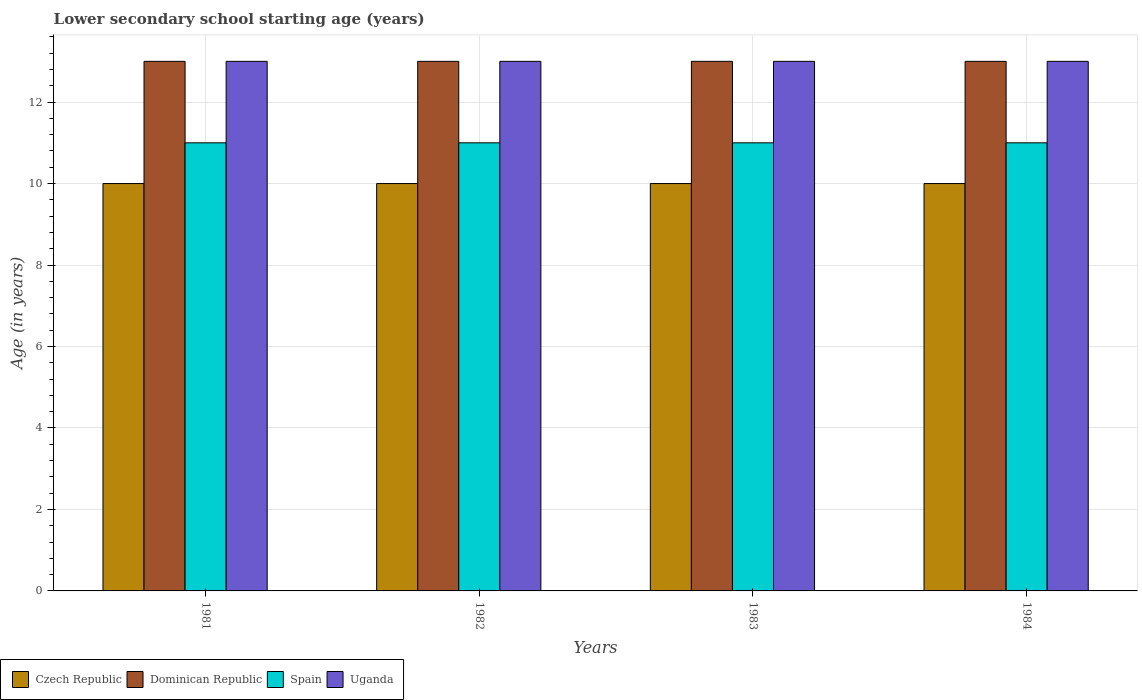How many different coloured bars are there?
Keep it short and to the point. 4. Are the number of bars per tick equal to the number of legend labels?
Give a very brief answer. Yes. In how many cases, is the number of bars for a given year not equal to the number of legend labels?
Your answer should be very brief. 0. What is the lower secondary school starting age of children in Uganda in 1984?
Provide a short and direct response. 13. Across all years, what is the maximum lower secondary school starting age of children in Spain?
Your response must be concise. 11. Across all years, what is the minimum lower secondary school starting age of children in Czech Republic?
Your answer should be very brief. 10. What is the total lower secondary school starting age of children in Czech Republic in the graph?
Offer a terse response. 40. What is the difference between the lower secondary school starting age of children in Dominican Republic in 1981 and that in 1983?
Your response must be concise. 0. What is the difference between the lower secondary school starting age of children in Czech Republic in 1982 and the lower secondary school starting age of children in Dominican Republic in 1983?
Offer a terse response. -3. In the year 1984, what is the difference between the lower secondary school starting age of children in Uganda and lower secondary school starting age of children in Czech Republic?
Ensure brevity in your answer.  3. In how many years, is the lower secondary school starting age of children in Dominican Republic greater than 8.8 years?
Provide a short and direct response. 4. What is the ratio of the lower secondary school starting age of children in Spain in 1981 to that in 1982?
Your response must be concise. 1. Is the lower secondary school starting age of children in Dominican Republic in 1981 less than that in 1984?
Your answer should be very brief. No. What is the difference between the highest and the lowest lower secondary school starting age of children in Spain?
Make the answer very short. 0. Is it the case that in every year, the sum of the lower secondary school starting age of children in Spain and lower secondary school starting age of children in Dominican Republic is greater than the sum of lower secondary school starting age of children in Uganda and lower secondary school starting age of children in Czech Republic?
Make the answer very short. Yes. What does the 2nd bar from the left in 1982 represents?
Provide a succinct answer. Dominican Republic. What does the 3rd bar from the right in 1984 represents?
Offer a terse response. Dominican Republic. How many bars are there?
Give a very brief answer. 16. Are all the bars in the graph horizontal?
Offer a terse response. No. How many years are there in the graph?
Provide a short and direct response. 4. What is the difference between two consecutive major ticks on the Y-axis?
Your answer should be very brief. 2. Are the values on the major ticks of Y-axis written in scientific E-notation?
Make the answer very short. No. Does the graph contain any zero values?
Offer a terse response. No. Does the graph contain grids?
Your answer should be very brief. Yes. Where does the legend appear in the graph?
Your answer should be compact. Bottom left. How are the legend labels stacked?
Ensure brevity in your answer.  Horizontal. What is the title of the graph?
Your response must be concise. Lower secondary school starting age (years). What is the label or title of the X-axis?
Ensure brevity in your answer.  Years. What is the label or title of the Y-axis?
Your answer should be very brief. Age (in years). What is the Age (in years) of Czech Republic in 1982?
Keep it short and to the point. 10. What is the Age (in years) in Czech Republic in 1983?
Ensure brevity in your answer.  10. What is the Age (in years) in Uganda in 1983?
Keep it short and to the point. 13. What is the Age (in years) of Czech Republic in 1984?
Provide a succinct answer. 10. What is the Age (in years) in Dominican Republic in 1984?
Offer a terse response. 13. Across all years, what is the minimum Age (in years) of Dominican Republic?
Your answer should be very brief. 13. What is the total Age (in years) of Spain in the graph?
Your response must be concise. 44. What is the difference between the Age (in years) of Dominican Republic in 1981 and that in 1982?
Provide a short and direct response. 0. What is the difference between the Age (in years) of Spain in 1981 and that in 1982?
Ensure brevity in your answer.  0. What is the difference between the Age (in years) in Uganda in 1981 and that in 1982?
Offer a very short reply. 0. What is the difference between the Age (in years) of Dominican Republic in 1981 and that in 1983?
Your response must be concise. 0. What is the difference between the Age (in years) of Spain in 1981 and that in 1983?
Your response must be concise. 0. What is the difference between the Age (in years) of Czech Republic in 1981 and that in 1984?
Make the answer very short. 0. What is the difference between the Age (in years) of Dominican Republic in 1981 and that in 1984?
Keep it short and to the point. 0. What is the difference between the Age (in years) of Spain in 1981 and that in 1984?
Your answer should be compact. 0. What is the difference between the Age (in years) of Czech Republic in 1982 and that in 1983?
Offer a very short reply. 0. What is the difference between the Age (in years) in Dominican Republic in 1982 and that in 1984?
Provide a short and direct response. 0. What is the difference between the Age (in years) in Spain in 1982 and that in 1984?
Your response must be concise. 0. What is the difference between the Age (in years) in Czech Republic in 1983 and that in 1984?
Keep it short and to the point. 0. What is the difference between the Age (in years) in Dominican Republic in 1983 and that in 1984?
Your answer should be compact. 0. What is the difference between the Age (in years) of Uganda in 1983 and that in 1984?
Make the answer very short. 0. What is the difference between the Age (in years) in Czech Republic in 1981 and the Age (in years) in Uganda in 1982?
Offer a very short reply. -3. What is the difference between the Age (in years) of Dominican Republic in 1981 and the Age (in years) of Uganda in 1982?
Provide a succinct answer. 0. What is the difference between the Age (in years) in Czech Republic in 1981 and the Age (in years) in Dominican Republic in 1983?
Make the answer very short. -3. What is the difference between the Age (in years) of Dominican Republic in 1981 and the Age (in years) of Spain in 1983?
Your answer should be compact. 2. What is the difference between the Age (in years) of Czech Republic in 1981 and the Age (in years) of Dominican Republic in 1984?
Keep it short and to the point. -3. What is the difference between the Age (in years) of Czech Republic in 1981 and the Age (in years) of Spain in 1984?
Make the answer very short. -1. What is the difference between the Age (in years) of Czech Republic in 1981 and the Age (in years) of Uganda in 1984?
Provide a succinct answer. -3. What is the difference between the Age (in years) of Czech Republic in 1982 and the Age (in years) of Spain in 1983?
Your response must be concise. -1. What is the difference between the Age (in years) of Dominican Republic in 1982 and the Age (in years) of Spain in 1983?
Offer a very short reply. 2. What is the difference between the Age (in years) of Dominican Republic in 1982 and the Age (in years) of Uganda in 1983?
Your response must be concise. 0. What is the difference between the Age (in years) of Czech Republic in 1982 and the Age (in years) of Dominican Republic in 1984?
Provide a short and direct response. -3. What is the difference between the Age (in years) of Czech Republic in 1982 and the Age (in years) of Spain in 1984?
Ensure brevity in your answer.  -1. What is the difference between the Age (in years) in Czech Republic in 1982 and the Age (in years) in Uganda in 1984?
Keep it short and to the point. -3. What is the difference between the Age (in years) of Dominican Republic in 1982 and the Age (in years) of Uganda in 1984?
Keep it short and to the point. 0. What is the difference between the Age (in years) in Spain in 1982 and the Age (in years) in Uganda in 1984?
Give a very brief answer. -2. What is the difference between the Age (in years) in Czech Republic in 1983 and the Age (in years) in Spain in 1984?
Your answer should be compact. -1. What is the difference between the Age (in years) of Dominican Republic in 1983 and the Age (in years) of Spain in 1984?
Offer a very short reply. 2. What is the difference between the Age (in years) in Spain in 1983 and the Age (in years) in Uganda in 1984?
Offer a terse response. -2. What is the average Age (in years) of Czech Republic per year?
Your answer should be compact. 10. What is the average Age (in years) in Uganda per year?
Offer a very short reply. 13. In the year 1981, what is the difference between the Age (in years) in Czech Republic and Age (in years) in Uganda?
Provide a succinct answer. -3. In the year 1981, what is the difference between the Age (in years) in Dominican Republic and Age (in years) in Spain?
Provide a succinct answer. 2. In the year 1981, what is the difference between the Age (in years) in Spain and Age (in years) in Uganda?
Provide a succinct answer. -2. In the year 1982, what is the difference between the Age (in years) in Czech Republic and Age (in years) in Spain?
Make the answer very short. -1. In the year 1982, what is the difference between the Age (in years) in Czech Republic and Age (in years) in Uganda?
Make the answer very short. -3. In the year 1982, what is the difference between the Age (in years) in Dominican Republic and Age (in years) in Spain?
Offer a terse response. 2. In the year 1982, what is the difference between the Age (in years) in Dominican Republic and Age (in years) in Uganda?
Provide a succinct answer. 0. In the year 1982, what is the difference between the Age (in years) in Spain and Age (in years) in Uganda?
Make the answer very short. -2. In the year 1983, what is the difference between the Age (in years) of Czech Republic and Age (in years) of Dominican Republic?
Provide a short and direct response. -3. In the year 1983, what is the difference between the Age (in years) in Czech Republic and Age (in years) in Spain?
Ensure brevity in your answer.  -1. In the year 1983, what is the difference between the Age (in years) in Czech Republic and Age (in years) in Uganda?
Provide a short and direct response. -3. In the year 1983, what is the difference between the Age (in years) of Dominican Republic and Age (in years) of Spain?
Make the answer very short. 2. In the year 1983, what is the difference between the Age (in years) of Dominican Republic and Age (in years) of Uganda?
Your answer should be compact. 0. In the year 1984, what is the difference between the Age (in years) in Czech Republic and Age (in years) in Uganda?
Give a very brief answer. -3. In the year 1984, what is the difference between the Age (in years) of Dominican Republic and Age (in years) of Spain?
Offer a terse response. 2. In the year 1984, what is the difference between the Age (in years) of Dominican Republic and Age (in years) of Uganda?
Provide a short and direct response. 0. In the year 1984, what is the difference between the Age (in years) of Spain and Age (in years) of Uganda?
Offer a terse response. -2. What is the ratio of the Age (in years) in Czech Republic in 1981 to that in 1983?
Your response must be concise. 1. What is the ratio of the Age (in years) of Dominican Republic in 1981 to that in 1983?
Give a very brief answer. 1. What is the ratio of the Age (in years) of Spain in 1981 to that in 1983?
Make the answer very short. 1. What is the ratio of the Age (in years) in Czech Republic in 1981 to that in 1984?
Offer a very short reply. 1. What is the ratio of the Age (in years) of Dominican Republic in 1981 to that in 1984?
Provide a succinct answer. 1. What is the ratio of the Age (in years) of Spain in 1981 to that in 1984?
Offer a terse response. 1. What is the ratio of the Age (in years) of Czech Republic in 1982 to that in 1983?
Offer a terse response. 1. What is the ratio of the Age (in years) of Dominican Republic in 1982 to that in 1983?
Offer a very short reply. 1. What is the ratio of the Age (in years) of Spain in 1982 to that in 1983?
Your answer should be compact. 1. What is the ratio of the Age (in years) of Czech Republic in 1982 to that in 1984?
Provide a succinct answer. 1. What is the ratio of the Age (in years) in Uganda in 1982 to that in 1984?
Give a very brief answer. 1. What is the ratio of the Age (in years) in Dominican Republic in 1983 to that in 1984?
Ensure brevity in your answer.  1. What is the ratio of the Age (in years) in Spain in 1983 to that in 1984?
Offer a very short reply. 1. What is the difference between the highest and the second highest Age (in years) of Dominican Republic?
Provide a short and direct response. 0. What is the difference between the highest and the second highest Age (in years) in Spain?
Provide a succinct answer. 0. What is the difference between the highest and the second highest Age (in years) of Uganda?
Make the answer very short. 0. What is the difference between the highest and the lowest Age (in years) in Spain?
Provide a short and direct response. 0. What is the difference between the highest and the lowest Age (in years) in Uganda?
Offer a terse response. 0. 